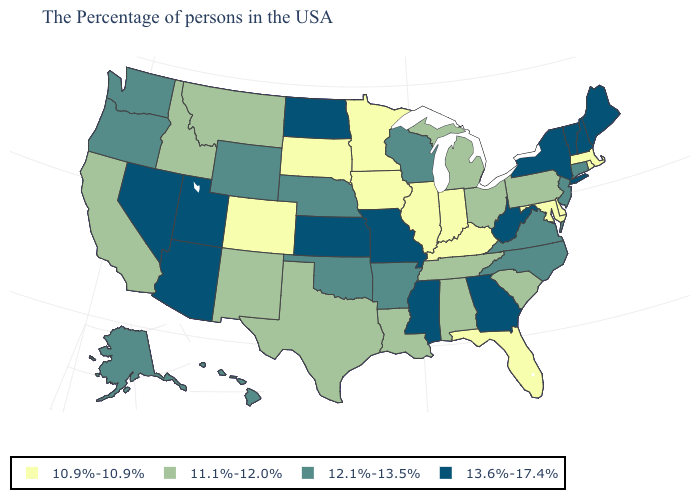How many symbols are there in the legend?
Concise answer only. 4. What is the value of Rhode Island?
Be succinct. 10.9%-10.9%. Name the states that have a value in the range 12.1%-13.5%?
Quick response, please. Connecticut, New Jersey, Virginia, North Carolina, Wisconsin, Arkansas, Nebraska, Oklahoma, Wyoming, Washington, Oregon, Alaska, Hawaii. Among the states that border Virginia , which have the highest value?
Short answer required. West Virginia. Among the states that border Pennsylvania , does West Virginia have the lowest value?
Answer briefly. No. What is the value of Nebraska?
Give a very brief answer. 12.1%-13.5%. Name the states that have a value in the range 11.1%-12.0%?
Be succinct. Pennsylvania, South Carolina, Ohio, Michigan, Alabama, Tennessee, Louisiana, Texas, New Mexico, Montana, Idaho, California. Among the states that border South Dakota , does Minnesota have the lowest value?
Quick response, please. Yes. Does the first symbol in the legend represent the smallest category?
Keep it brief. Yes. Does Alaska have the highest value in the USA?
Give a very brief answer. No. Does Idaho have a higher value than Illinois?
Concise answer only. Yes. What is the lowest value in states that border New Mexico?
Give a very brief answer. 10.9%-10.9%. Which states have the highest value in the USA?
Write a very short answer. Maine, New Hampshire, Vermont, New York, West Virginia, Georgia, Mississippi, Missouri, Kansas, North Dakota, Utah, Arizona, Nevada. Name the states that have a value in the range 12.1%-13.5%?
Keep it brief. Connecticut, New Jersey, Virginia, North Carolina, Wisconsin, Arkansas, Nebraska, Oklahoma, Wyoming, Washington, Oregon, Alaska, Hawaii. Name the states that have a value in the range 11.1%-12.0%?
Give a very brief answer. Pennsylvania, South Carolina, Ohio, Michigan, Alabama, Tennessee, Louisiana, Texas, New Mexico, Montana, Idaho, California. 